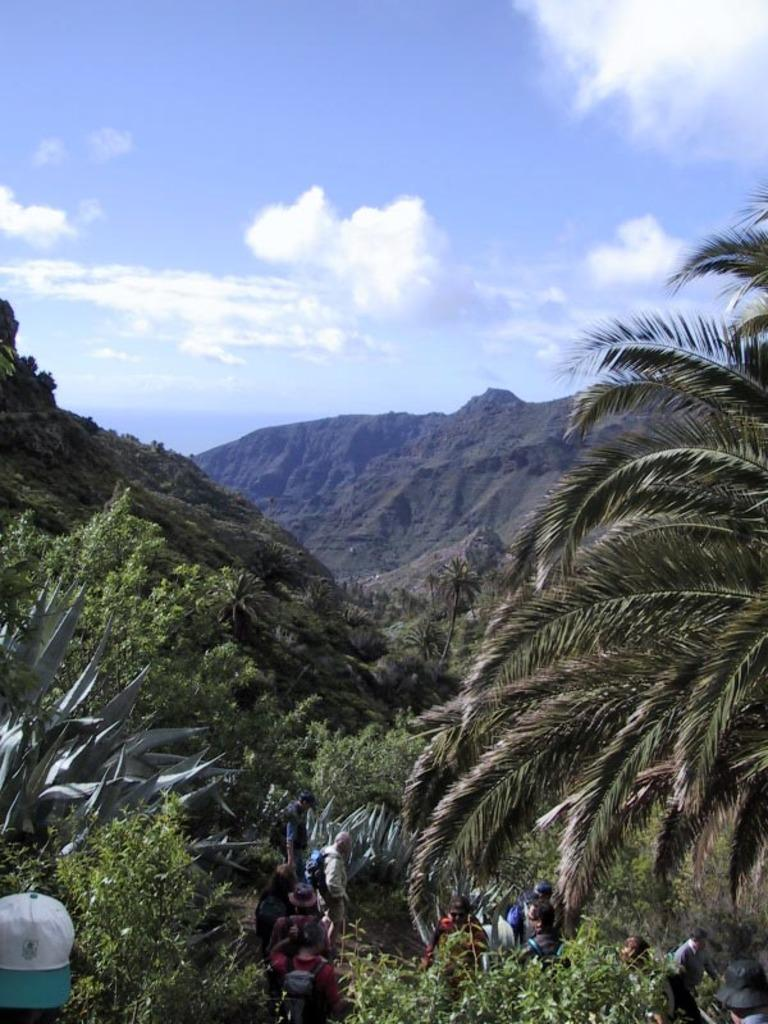What type of natural elements can be seen in the image? There are trees and clouds in the image. What part of the natural environment is visible in the image? The sky is visible in the image. Can you describe the people in the image? There are people in the image, and some of them are wearing caps and carrying bags. What is the interest rate of the loan being discussed by the people in the image? There is no indication in the image that the people are discussing a loan or any financial matters, so it cannot be determined from the picture. 